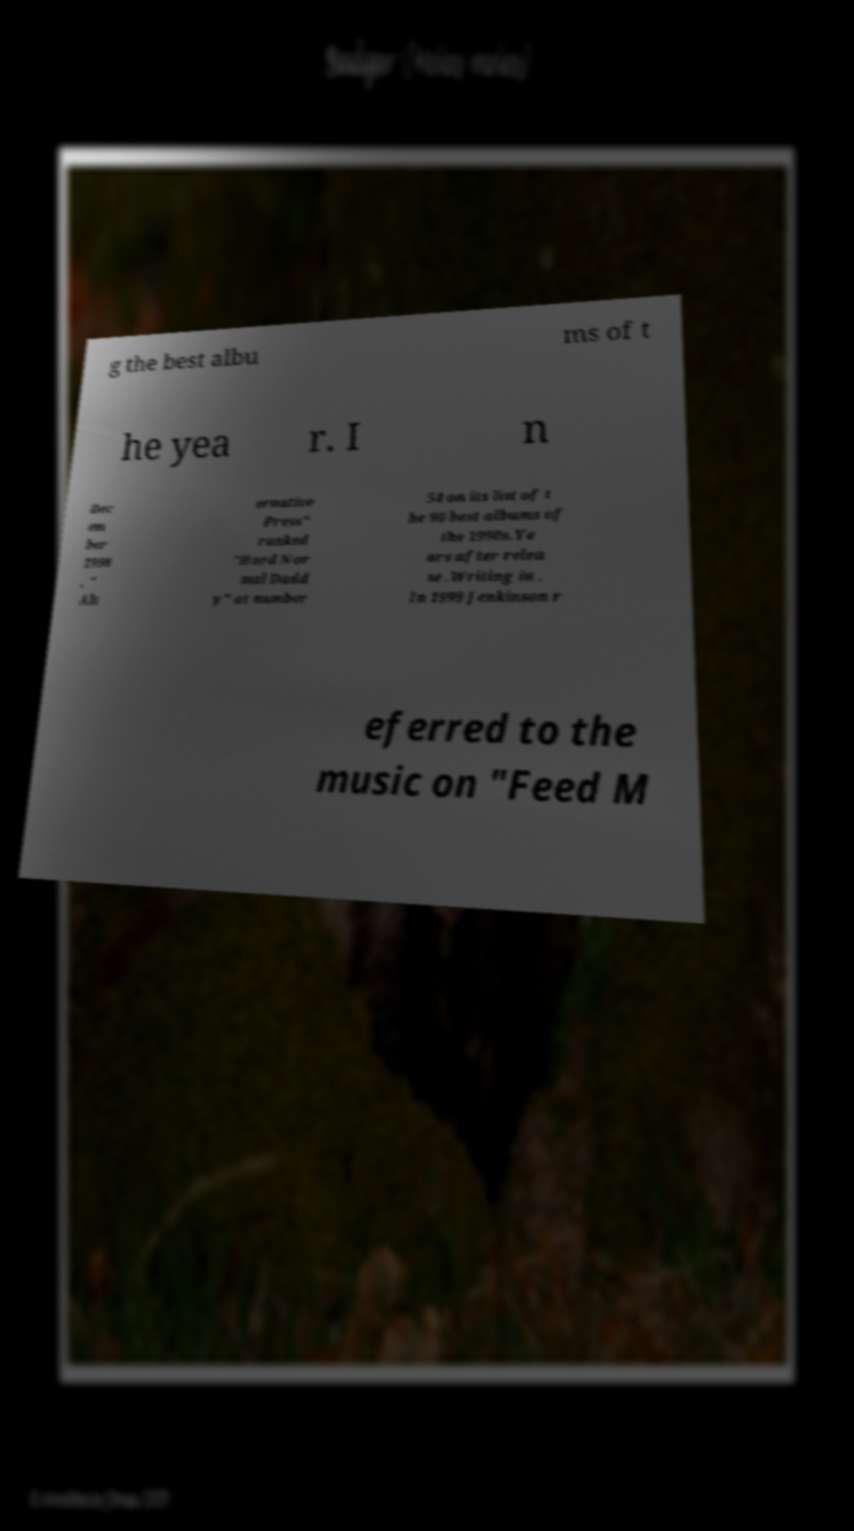Please read and relay the text visible in this image. What does it say? g the best albu ms of t he yea r. I n Dec em ber 1998 , " Alt ernative Press" ranked "Hard Nor mal Dadd y" at number 54 on its list of t he 90 best albums of the 1990s.Ye ars after relea se .Writing in . In 1999 Jenkinson r eferred to the music on "Feed M 